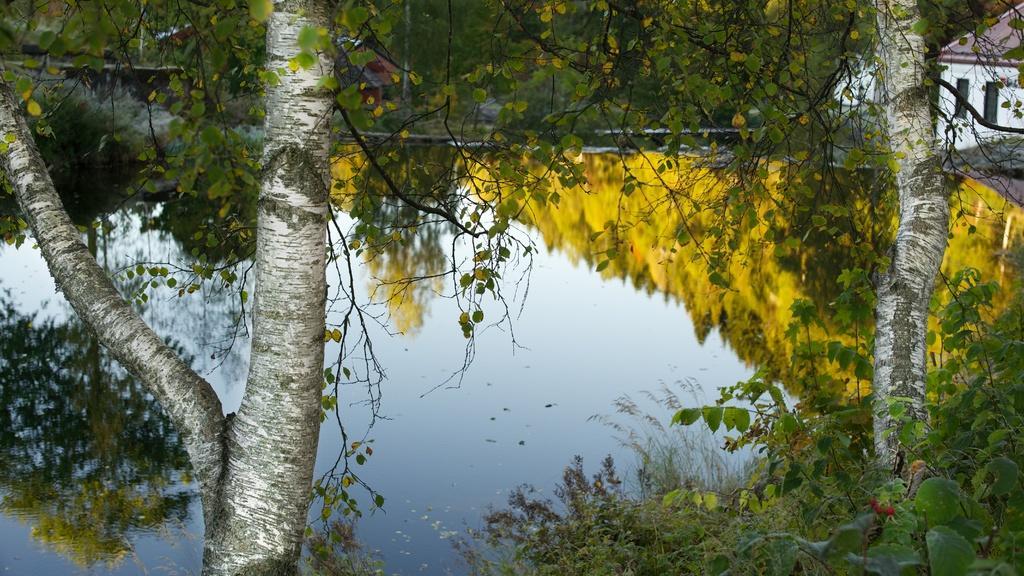In one or two sentences, can you explain what this image depicts? In this picture I can see a house, there are plants, there is a reflection of trees and sky on the water. 